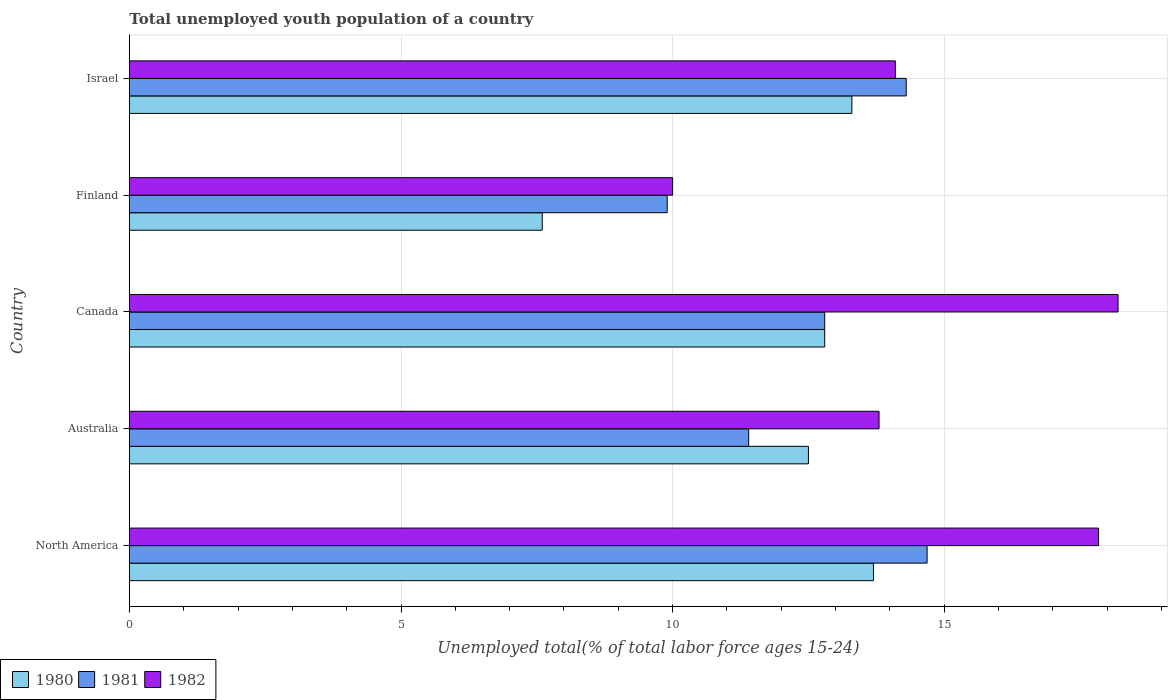How many groups of bars are there?
Make the answer very short. 5. Are the number of bars per tick equal to the number of legend labels?
Offer a terse response. Yes. How many bars are there on the 4th tick from the top?
Ensure brevity in your answer.  3. How many bars are there on the 1st tick from the bottom?
Your response must be concise. 3. In how many cases, is the number of bars for a given country not equal to the number of legend labels?
Keep it short and to the point. 0. What is the percentage of total unemployed youth population of a country in 1980 in Finland?
Provide a succinct answer. 7.6. Across all countries, what is the maximum percentage of total unemployed youth population of a country in 1980?
Your answer should be compact. 13.7. In which country was the percentage of total unemployed youth population of a country in 1982 minimum?
Your answer should be very brief. Finland. What is the total percentage of total unemployed youth population of a country in 1980 in the graph?
Make the answer very short. 59.9. What is the difference between the percentage of total unemployed youth population of a country in 1981 in Australia and that in Canada?
Offer a terse response. -1.4. What is the difference between the percentage of total unemployed youth population of a country in 1982 in Finland and the percentage of total unemployed youth population of a country in 1981 in Australia?
Offer a terse response. -1.4. What is the average percentage of total unemployed youth population of a country in 1982 per country?
Give a very brief answer. 14.79. What is the difference between the percentage of total unemployed youth population of a country in 1982 and percentage of total unemployed youth population of a country in 1981 in Australia?
Your answer should be very brief. 2.4. What is the ratio of the percentage of total unemployed youth population of a country in 1982 in Australia to that in Israel?
Offer a terse response. 0.98. Is the percentage of total unemployed youth population of a country in 1981 in Australia less than that in Israel?
Your response must be concise. Yes. Is the difference between the percentage of total unemployed youth population of a country in 1982 in Finland and North America greater than the difference between the percentage of total unemployed youth population of a country in 1981 in Finland and North America?
Offer a terse response. No. What is the difference between the highest and the second highest percentage of total unemployed youth population of a country in 1982?
Offer a very short reply. 0.36. What is the difference between the highest and the lowest percentage of total unemployed youth population of a country in 1981?
Provide a short and direct response. 4.78. In how many countries, is the percentage of total unemployed youth population of a country in 1982 greater than the average percentage of total unemployed youth population of a country in 1982 taken over all countries?
Keep it short and to the point. 2. What does the 3rd bar from the top in North America represents?
Ensure brevity in your answer.  1980. How many bars are there?
Your answer should be compact. 15. How many countries are there in the graph?
Ensure brevity in your answer.  5. What is the difference between two consecutive major ticks on the X-axis?
Provide a succinct answer. 5. Does the graph contain any zero values?
Provide a succinct answer. No. Where does the legend appear in the graph?
Offer a very short reply. Bottom left. How are the legend labels stacked?
Your response must be concise. Horizontal. What is the title of the graph?
Give a very brief answer. Total unemployed youth population of a country. What is the label or title of the X-axis?
Give a very brief answer. Unemployed total(% of total labor force ages 15-24). What is the Unemployed total(% of total labor force ages 15-24) in 1980 in North America?
Ensure brevity in your answer.  13.7. What is the Unemployed total(% of total labor force ages 15-24) of 1981 in North America?
Give a very brief answer. 14.68. What is the Unemployed total(% of total labor force ages 15-24) of 1982 in North America?
Keep it short and to the point. 17.84. What is the Unemployed total(% of total labor force ages 15-24) of 1981 in Australia?
Offer a very short reply. 11.4. What is the Unemployed total(% of total labor force ages 15-24) in 1982 in Australia?
Give a very brief answer. 13.8. What is the Unemployed total(% of total labor force ages 15-24) in 1980 in Canada?
Ensure brevity in your answer.  12.8. What is the Unemployed total(% of total labor force ages 15-24) of 1981 in Canada?
Make the answer very short. 12.8. What is the Unemployed total(% of total labor force ages 15-24) in 1982 in Canada?
Provide a short and direct response. 18.2. What is the Unemployed total(% of total labor force ages 15-24) in 1980 in Finland?
Your answer should be compact. 7.6. What is the Unemployed total(% of total labor force ages 15-24) in 1981 in Finland?
Your answer should be compact. 9.9. What is the Unemployed total(% of total labor force ages 15-24) of 1980 in Israel?
Keep it short and to the point. 13.3. What is the Unemployed total(% of total labor force ages 15-24) of 1981 in Israel?
Your response must be concise. 14.3. What is the Unemployed total(% of total labor force ages 15-24) in 1982 in Israel?
Ensure brevity in your answer.  14.1. Across all countries, what is the maximum Unemployed total(% of total labor force ages 15-24) in 1980?
Your answer should be compact. 13.7. Across all countries, what is the maximum Unemployed total(% of total labor force ages 15-24) of 1981?
Provide a short and direct response. 14.68. Across all countries, what is the maximum Unemployed total(% of total labor force ages 15-24) in 1982?
Keep it short and to the point. 18.2. Across all countries, what is the minimum Unemployed total(% of total labor force ages 15-24) of 1980?
Keep it short and to the point. 7.6. Across all countries, what is the minimum Unemployed total(% of total labor force ages 15-24) of 1981?
Offer a terse response. 9.9. Across all countries, what is the minimum Unemployed total(% of total labor force ages 15-24) in 1982?
Give a very brief answer. 10. What is the total Unemployed total(% of total labor force ages 15-24) in 1980 in the graph?
Provide a short and direct response. 59.9. What is the total Unemployed total(% of total labor force ages 15-24) of 1981 in the graph?
Offer a very short reply. 63.08. What is the total Unemployed total(% of total labor force ages 15-24) of 1982 in the graph?
Provide a succinct answer. 73.94. What is the difference between the Unemployed total(% of total labor force ages 15-24) of 1980 in North America and that in Australia?
Give a very brief answer. 1.2. What is the difference between the Unemployed total(% of total labor force ages 15-24) of 1981 in North America and that in Australia?
Your answer should be very brief. 3.28. What is the difference between the Unemployed total(% of total labor force ages 15-24) of 1982 in North America and that in Australia?
Provide a short and direct response. 4.04. What is the difference between the Unemployed total(% of total labor force ages 15-24) in 1980 in North America and that in Canada?
Make the answer very short. 0.9. What is the difference between the Unemployed total(% of total labor force ages 15-24) in 1981 in North America and that in Canada?
Make the answer very short. 1.88. What is the difference between the Unemployed total(% of total labor force ages 15-24) of 1982 in North America and that in Canada?
Provide a succinct answer. -0.36. What is the difference between the Unemployed total(% of total labor force ages 15-24) in 1980 in North America and that in Finland?
Provide a short and direct response. 6.1. What is the difference between the Unemployed total(% of total labor force ages 15-24) in 1981 in North America and that in Finland?
Give a very brief answer. 4.78. What is the difference between the Unemployed total(% of total labor force ages 15-24) in 1982 in North America and that in Finland?
Make the answer very short. 7.84. What is the difference between the Unemployed total(% of total labor force ages 15-24) in 1980 in North America and that in Israel?
Keep it short and to the point. 0.4. What is the difference between the Unemployed total(% of total labor force ages 15-24) in 1981 in North America and that in Israel?
Provide a short and direct response. 0.38. What is the difference between the Unemployed total(% of total labor force ages 15-24) in 1982 in North America and that in Israel?
Your answer should be very brief. 3.74. What is the difference between the Unemployed total(% of total labor force ages 15-24) of 1981 in Australia and that in Canada?
Provide a short and direct response. -1.4. What is the difference between the Unemployed total(% of total labor force ages 15-24) in 1982 in Australia and that in Canada?
Your answer should be compact. -4.4. What is the difference between the Unemployed total(% of total labor force ages 15-24) in 1981 in Australia and that in Finland?
Offer a very short reply. 1.5. What is the difference between the Unemployed total(% of total labor force ages 15-24) in 1982 in Australia and that in Israel?
Your answer should be compact. -0.3. What is the difference between the Unemployed total(% of total labor force ages 15-24) of 1980 in Canada and that in Finland?
Ensure brevity in your answer.  5.2. What is the difference between the Unemployed total(% of total labor force ages 15-24) of 1981 in Canada and that in Finland?
Keep it short and to the point. 2.9. What is the difference between the Unemployed total(% of total labor force ages 15-24) of 1980 in Canada and that in Israel?
Make the answer very short. -0.5. What is the difference between the Unemployed total(% of total labor force ages 15-24) in 1981 in Canada and that in Israel?
Offer a terse response. -1.5. What is the difference between the Unemployed total(% of total labor force ages 15-24) in 1982 in Canada and that in Israel?
Your answer should be compact. 4.1. What is the difference between the Unemployed total(% of total labor force ages 15-24) in 1980 in North America and the Unemployed total(% of total labor force ages 15-24) in 1981 in Australia?
Make the answer very short. 2.3. What is the difference between the Unemployed total(% of total labor force ages 15-24) of 1980 in North America and the Unemployed total(% of total labor force ages 15-24) of 1982 in Australia?
Provide a short and direct response. -0.1. What is the difference between the Unemployed total(% of total labor force ages 15-24) in 1981 in North America and the Unemployed total(% of total labor force ages 15-24) in 1982 in Australia?
Provide a succinct answer. 0.88. What is the difference between the Unemployed total(% of total labor force ages 15-24) in 1980 in North America and the Unemployed total(% of total labor force ages 15-24) in 1981 in Canada?
Make the answer very short. 0.9. What is the difference between the Unemployed total(% of total labor force ages 15-24) in 1980 in North America and the Unemployed total(% of total labor force ages 15-24) in 1982 in Canada?
Ensure brevity in your answer.  -4.5. What is the difference between the Unemployed total(% of total labor force ages 15-24) in 1981 in North America and the Unemployed total(% of total labor force ages 15-24) in 1982 in Canada?
Ensure brevity in your answer.  -3.52. What is the difference between the Unemployed total(% of total labor force ages 15-24) of 1980 in North America and the Unemployed total(% of total labor force ages 15-24) of 1981 in Finland?
Give a very brief answer. 3.8. What is the difference between the Unemployed total(% of total labor force ages 15-24) in 1980 in North America and the Unemployed total(% of total labor force ages 15-24) in 1982 in Finland?
Offer a terse response. 3.7. What is the difference between the Unemployed total(% of total labor force ages 15-24) of 1981 in North America and the Unemployed total(% of total labor force ages 15-24) of 1982 in Finland?
Make the answer very short. 4.68. What is the difference between the Unemployed total(% of total labor force ages 15-24) of 1980 in North America and the Unemployed total(% of total labor force ages 15-24) of 1981 in Israel?
Provide a succinct answer. -0.6. What is the difference between the Unemployed total(% of total labor force ages 15-24) in 1980 in North America and the Unemployed total(% of total labor force ages 15-24) in 1982 in Israel?
Ensure brevity in your answer.  -0.4. What is the difference between the Unemployed total(% of total labor force ages 15-24) in 1981 in North America and the Unemployed total(% of total labor force ages 15-24) in 1982 in Israel?
Keep it short and to the point. 0.58. What is the difference between the Unemployed total(% of total labor force ages 15-24) in 1980 in Australia and the Unemployed total(% of total labor force ages 15-24) in 1981 in Canada?
Offer a terse response. -0.3. What is the difference between the Unemployed total(% of total labor force ages 15-24) in 1980 in Canada and the Unemployed total(% of total labor force ages 15-24) in 1982 in Finland?
Provide a short and direct response. 2.8. What is the difference between the Unemployed total(% of total labor force ages 15-24) of 1980 in Canada and the Unemployed total(% of total labor force ages 15-24) of 1981 in Israel?
Provide a succinct answer. -1.5. What is the difference between the Unemployed total(% of total labor force ages 15-24) of 1981 in Canada and the Unemployed total(% of total labor force ages 15-24) of 1982 in Israel?
Ensure brevity in your answer.  -1.3. What is the difference between the Unemployed total(% of total labor force ages 15-24) of 1980 in Finland and the Unemployed total(% of total labor force ages 15-24) of 1981 in Israel?
Your response must be concise. -6.7. What is the difference between the Unemployed total(% of total labor force ages 15-24) in 1980 in Finland and the Unemployed total(% of total labor force ages 15-24) in 1982 in Israel?
Your answer should be very brief. -6.5. What is the average Unemployed total(% of total labor force ages 15-24) in 1980 per country?
Provide a succinct answer. 11.98. What is the average Unemployed total(% of total labor force ages 15-24) in 1981 per country?
Ensure brevity in your answer.  12.62. What is the average Unemployed total(% of total labor force ages 15-24) in 1982 per country?
Give a very brief answer. 14.79. What is the difference between the Unemployed total(% of total labor force ages 15-24) of 1980 and Unemployed total(% of total labor force ages 15-24) of 1981 in North America?
Your answer should be compact. -0.99. What is the difference between the Unemployed total(% of total labor force ages 15-24) in 1980 and Unemployed total(% of total labor force ages 15-24) in 1982 in North America?
Offer a terse response. -4.14. What is the difference between the Unemployed total(% of total labor force ages 15-24) of 1981 and Unemployed total(% of total labor force ages 15-24) of 1982 in North America?
Keep it short and to the point. -3.16. What is the difference between the Unemployed total(% of total labor force ages 15-24) of 1980 and Unemployed total(% of total labor force ages 15-24) of 1981 in Canada?
Your response must be concise. 0. What is the difference between the Unemployed total(% of total labor force ages 15-24) in 1980 and Unemployed total(% of total labor force ages 15-24) in 1982 in Canada?
Offer a terse response. -5.4. What is the difference between the Unemployed total(% of total labor force ages 15-24) in 1981 and Unemployed total(% of total labor force ages 15-24) in 1982 in Israel?
Provide a short and direct response. 0.2. What is the ratio of the Unemployed total(% of total labor force ages 15-24) in 1980 in North America to that in Australia?
Ensure brevity in your answer.  1.1. What is the ratio of the Unemployed total(% of total labor force ages 15-24) of 1981 in North America to that in Australia?
Ensure brevity in your answer.  1.29. What is the ratio of the Unemployed total(% of total labor force ages 15-24) in 1982 in North America to that in Australia?
Keep it short and to the point. 1.29. What is the ratio of the Unemployed total(% of total labor force ages 15-24) in 1980 in North America to that in Canada?
Keep it short and to the point. 1.07. What is the ratio of the Unemployed total(% of total labor force ages 15-24) in 1981 in North America to that in Canada?
Keep it short and to the point. 1.15. What is the ratio of the Unemployed total(% of total labor force ages 15-24) in 1982 in North America to that in Canada?
Your response must be concise. 0.98. What is the ratio of the Unemployed total(% of total labor force ages 15-24) of 1980 in North America to that in Finland?
Provide a succinct answer. 1.8. What is the ratio of the Unemployed total(% of total labor force ages 15-24) of 1981 in North America to that in Finland?
Ensure brevity in your answer.  1.48. What is the ratio of the Unemployed total(% of total labor force ages 15-24) of 1982 in North America to that in Finland?
Offer a very short reply. 1.78. What is the ratio of the Unemployed total(% of total labor force ages 15-24) of 1980 in North America to that in Israel?
Offer a very short reply. 1.03. What is the ratio of the Unemployed total(% of total labor force ages 15-24) of 1981 in North America to that in Israel?
Your answer should be very brief. 1.03. What is the ratio of the Unemployed total(% of total labor force ages 15-24) of 1982 in North America to that in Israel?
Your answer should be compact. 1.27. What is the ratio of the Unemployed total(% of total labor force ages 15-24) in 1980 in Australia to that in Canada?
Your answer should be very brief. 0.98. What is the ratio of the Unemployed total(% of total labor force ages 15-24) in 1981 in Australia to that in Canada?
Provide a succinct answer. 0.89. What is the ratio of the Unemployed total(% of total labor force ages 15-24) in 1982 in Australia to that in Canada?
Give a very brief answer. 0.76. What is the ratio of the Unemployed total(% of total labor force ages 15-24) of 1980 in Australia to that in Finland?
Make the answer very short. 1.64. What is the ratio of the Unemployed total(% of total labor force ages 15-24) in 1981 in Australia to that in Finland?
Provide a succinct answer. 1.15. What is the ratio of the Unemployed total(% of total labor force ages 15-24) in 1982 in Australia to that in Finland?
Provide a short and direct response. 1.38. What is the ratio of the Unemployed total(% of total labor force ages 15-24) in 1980 in Australia to that in Israel?
Offer a very short reply. 0.94. What is the ratio of the Unemployed total(% of total labor force ages 15-24) of 1981 in Australia to that in Israel?
Ensure brevity in your answer.  0.8. What is the ratio of the Unemployed total(% of total labor force ages 15-24) of 1982 in Australia to that in Israel?
Your answer should be compact. 0.98. What is the ratio of the Unemployed total(% of total labor force ages 15-24) in 1980 in Canada to that in Finland?
Provide a short and direct response. 1.68. What is the ratio of the Unemployed total(% of total labor force ages 15-24) in 1981 in Canada to that in Finland?
Your answer should be very brief. 1.29. What is the ratio of the Unemployed total(% of total labor force ages 15-24) in 1982 in Canada to that in Finland?
Provide a succinct answer. 1.82. What is the ratio of the Unemployed total(% of total labor force ages 15-24) in 1980 in Canada to that in Israel?
Offer a very short reply. 0.96. What is the ratio of the Unemployed total(% of total labor force ages 15-24) of 1981 in Canada to that in Israel?
Your answer should be compact. 0.9. What is the ratio of the Unemployed total(% of total labor force ages 15-24) of 1982 in Canada to that in Israel?
Keep it short and to the point. 1.29. What is the ratio of the Unemployed total(% of total labor force ages 15-24) in 1980 in Finland to that in Israel?
Your response must be concise. 0.57. What is the ratio of the Unemployed total(% of total labor force ages 15-24) of 1981 in Finland to that in Israel?
Offer a terse response. 0.69. What is the ratio of the Unemployed total(% of total labor force ages 15-24) in 1982 in Finland to that in Israel?
Provide a short and direct response. 0.71. What is the difference between the highest and the second highest Unemployed total(% of total labor force ages 15-24) in 1980?
Your answer should be compact. 0.4. What is the difference between the highest and the second highest Unemployed total(% of total labor force ages 15-24) of 1981?
Make the answer very short. 0.38. What is the difference between the highest and the second highest Unemployed total(% of total labor force ages 15-24) of 1982?
Your answer should be very brief. 0.36. What is the difference between the highest and the lowest Unemployed total(% of total labor force ages 15-24) of 1980?
Give a very brief answer. 6.1. What is the difference between the highest and the lowest Unemployed total(% of total labor force ages 15-24) in 1981?
Give a very brief answer. 4.78. What is the difference between the highest and the lowest Unemployed total(% of total labor force ages 15-24) of 1982?
Your answer should be compact. 8.2. 